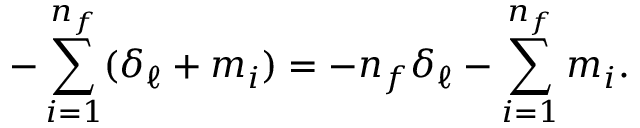<formula> <loc_0><loc_0><loc_500><loc_500>- \sum _ { i = 1 } ^ { n _ { f } } ( \delta _ { \ell } + m _ { i } ) = - n _ { f } \delta _ { \ell } - \sum _ { i = 1 } ^ { n _ { f } } m _ { i } .</formula> 